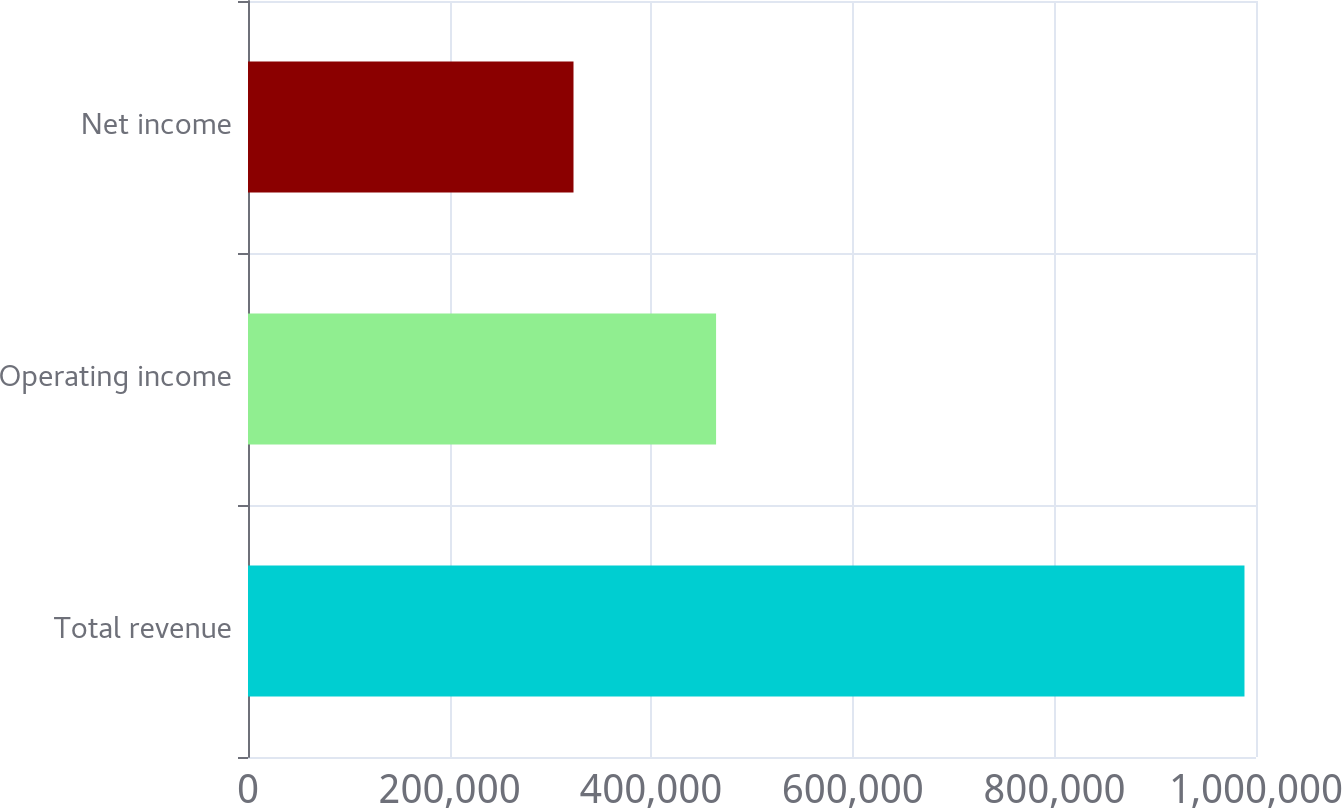Convert chart. <chart><loc_0><loc_0><loc_500><loc_500><bar_chart><fcel>Total revenue<fcel>Operating income<fcel>Net income<nl><fcel>988568<fcel>464356<fcel>322922<nl></chart> 